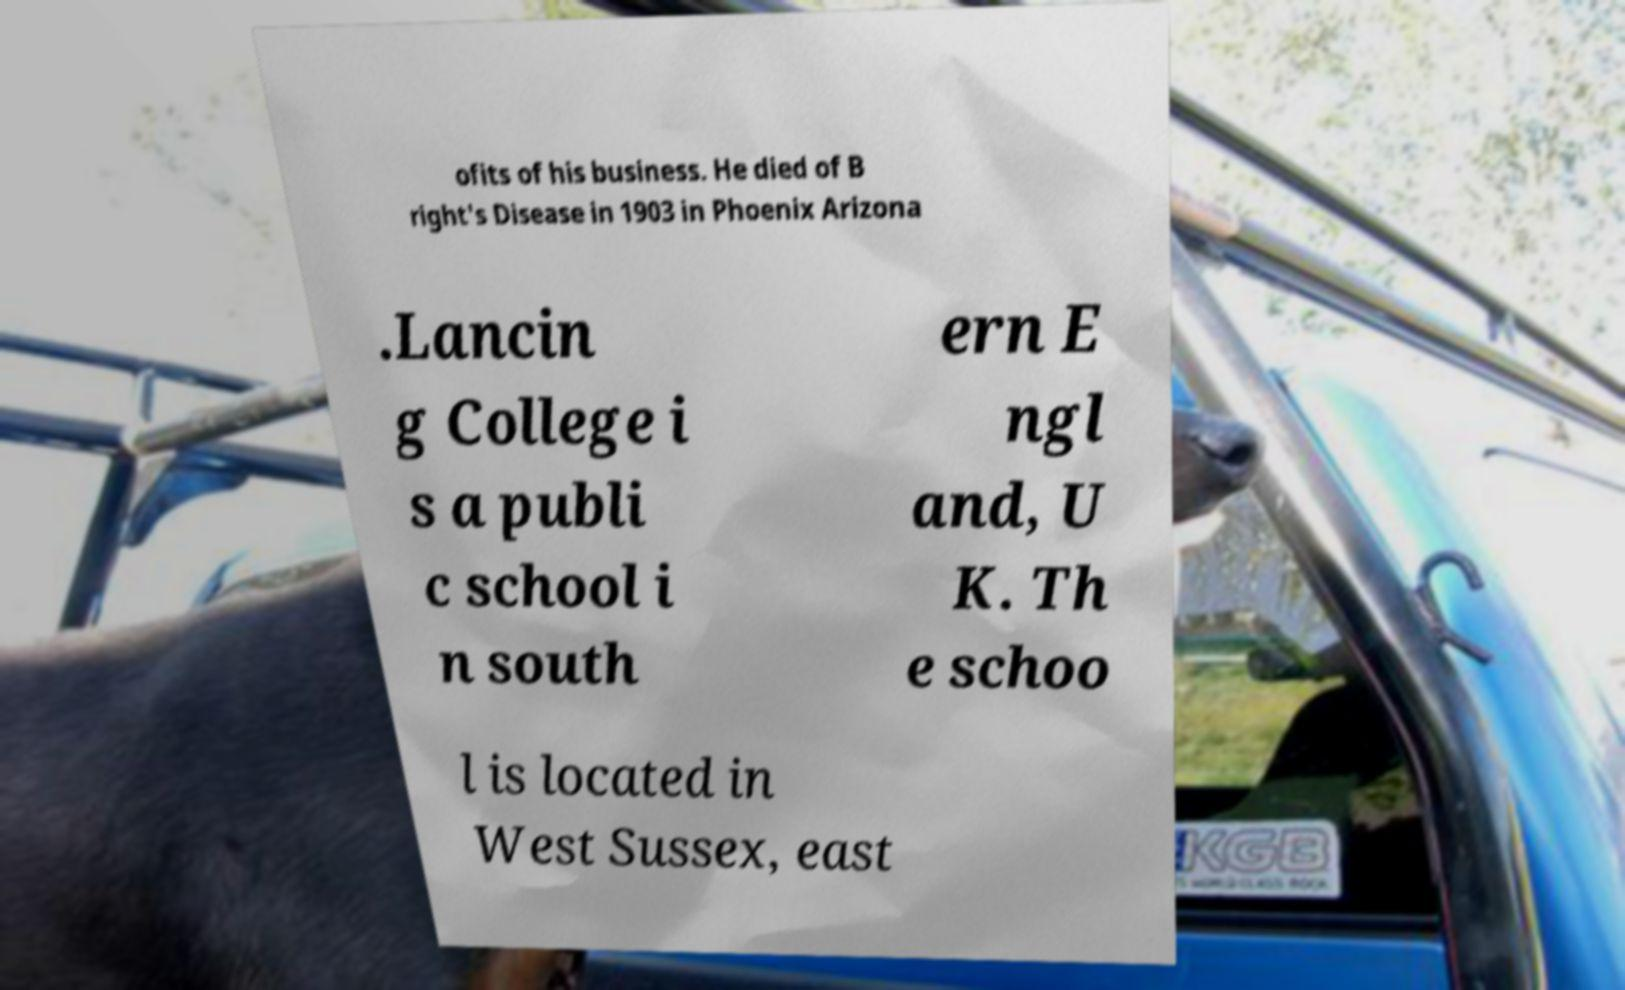Could you extract and type out the text from this image? ofits of his business. He died of B right's Disease in 1903 in Phoenix Arizona .Lancin g College i s a publi c school i n south ern E ngl and, U K. Th e schoo l is located in West Sussex, east 